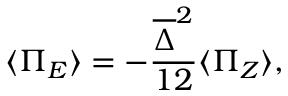Convert formula to latex. <formula><loc_0><loc_0><loc_500><loc_500>\langle \Pi _ { E } \rangle = - \frac { \overline { \Delta } ^ { 2 } } { 1 2 } \langle \Pi _ { Z } \rangle ,</formula> 